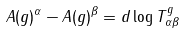<formula> <loc_0><loc_0><loc_500><loc_500>A ( g ) ^ { \alpha } - A ( g ) ^ { \beta } = d \log T _ { \alpha \beta } ^ { g }</formula> 